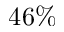Convert formula to latex. <formula><loc_0><loc_0><loc_500><loc_500>4 6 \%</formula> 